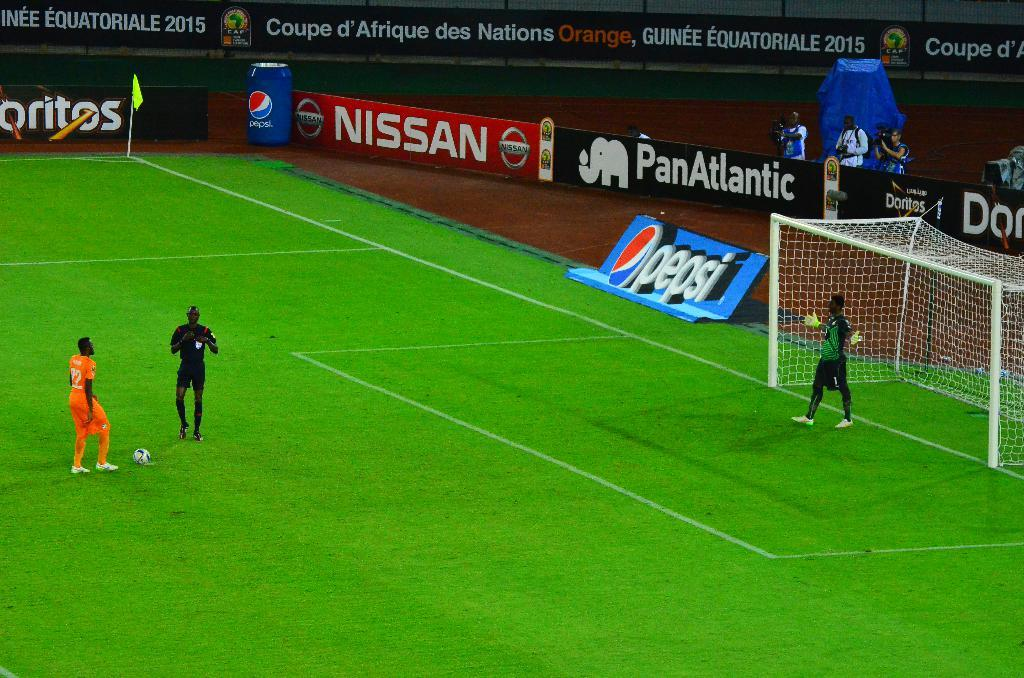Provide a one-sentence caption for the provided image. Soccer players stand on the field in front of a Pepsi and Nissan ad. 